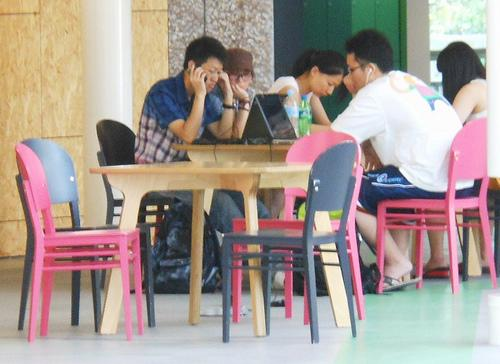Describe the situation of the empty chairs. The empty chairs are a bright pink one and a dark blue one, both are not in use. How many people are in the image and what are they doing? There are two people in the image. They are sitting at a table and studying with laptops and a cellphone. Explain what the woman and the man are involved in, paying attention to their respective accessories. The woman is looking at her laptop while wearing glasses and resting her chin in her hand. The man is using a cellphone and wearing earbuds, a white shirt, and shorts. List three objects you can see on the table in this image. Laptops, cellphone, and green plastic bottle with a blue cap. Identify the colors of the chairs in the image. The chairs are pink, blue, and black. What is the woman doing with her hand while looking at the laptop? The woman is resting her chin in her hand. What type of table is shown in the image? The table is wooden. Describe the type of chairs and how they are situated in the image. There are four chairs - a pink one, a blue one, a black one, and an unstated color one. The pink and blue chairs are empty, while the black one has a man sitting on it. What activity are the people engaged in? The people are studying using laptops and a cellphone. What type of bottle can be seen in the image? A green plastic bottle with a blue cap. 